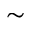<formula> <loc_0><loc_0><loc_500><loc_500>\sim</formula> 